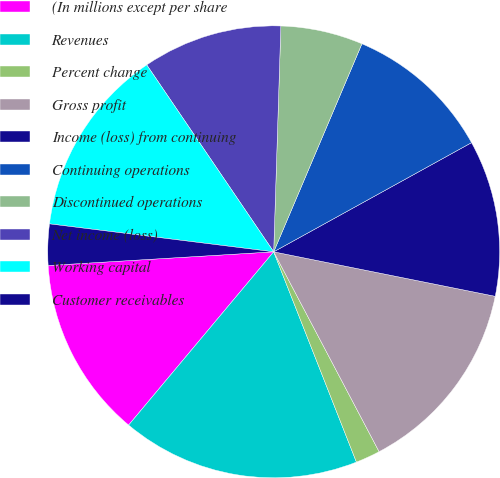Convert chart. <chart><loc_0><loc_0><loc_500><loc_500><pie_chart><fcel>(In millions except per share<fcel>Revenues<fcel>Percent change<fcel>Gross profit<fcel>Income (loss) from continuing<fcel>Continuing operations<fcel>Discontinued operations<fcel>Net income (loss)<fcel>Working capital<fcel>Customer receivables<nl><fcel>12.94%<fcel>17.06%<fcel>1.76%<fcel>14.12%<fcel>11.18%<fcel>10.59%<fcel>5.88%<fcel>10.0%<fcel>13.53%<fcel>2.94%<nl></chart> 